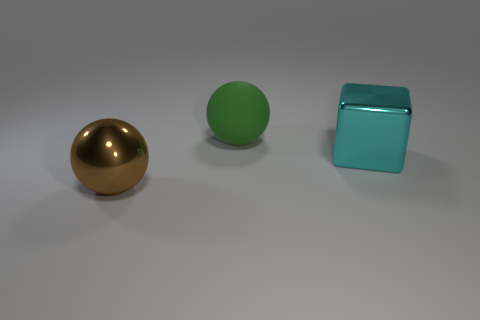Add 3 big matte things. How many objects exist? 6 Subtract 1 cubes. How many cubes are left? 0 Subtract all green balls. How many balls are left? 1 Subtract all balls. How many objects are left? 1 Add 3 small cyan metallic balls. How many small cyan metallic balls exist? 3 Subtract 0 green cylinders. How many objects are left? 3 Subtract all purple spheres. Subtract all yellow cubes. How many spheres are left? 2 Subtract all red cylinders. How many yellow balls are left? 0 Subtract all big cyan cubes. Subtract all large metal balls. How many objects are left? 1 Add 2 big metal cubes. How many big metal cubes are left? 3 